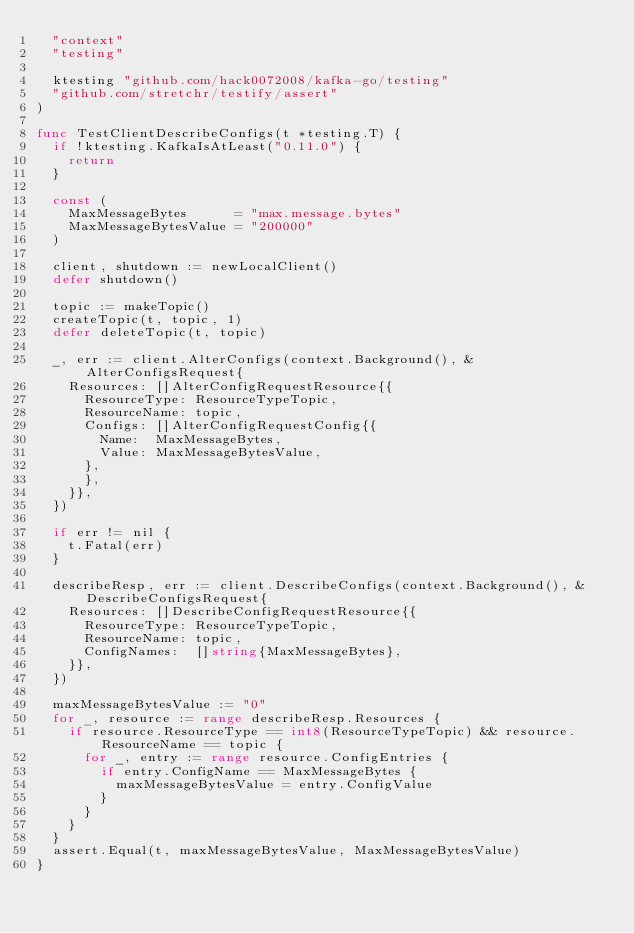Convert code to text. <code><loc_0><loc_0><loc_500><loc_500><_Go_>	"context"
	"testing"

	ktesting "github.com/hack0072008/kafka-go/testing"
	"github.com/stretchr/testify/assert"
)

func TestClientDescribeConfigs(t *testing.T) {
	if !ktesting.KafkaIsAtLeast("0.11.0") {
		return
	}

	const (
		MaxMessageBytes      = "max.message.bytes"
		MaxMessageBytesValue = "200000"
	)

	client, shutdown := newLocalClient()
	defer shutdown()

	topic := makeTopic()
	createTopic(t, topic, 1)
	defer deleteTopic(t, topic)

	_, err := client.AlterConfigs(context.Background(), &AlterConfigsRequest{
		Resources: []AlterConfigRequestResource{{
			ResourceType: ResourceTypeTopic,
			ResourceName: topic,
			Configs: []AlterConfigRequestConfig{{
				Name:  MaxMessageBytes,
				Value: MaxMessageBytesValue,
			},
			},
		}},
	})

	if err != nil {
		t.Fatal(err)
	}

	describeResp, err := client.DescribeConfigs(context.Background(), &DescribeConfigsRequest{
		Resources: []DescribeConfigRequestResource{{
			ResourceType: ResourceTypeTopic,
			ResourceName: topic,
			ConfigNames:  []string{MaxMessageBytes},
		}},
	})

	maxMessageBytesValue := "0"
	for _, resource := range describeResp.Resources {
		if resource.ResourceType == int8(ResourceTypeTopic) && resource.ResourceName == topic {
			for _, entry := range resource.ConfigEntries {
				if entry.ConfigName == MaxMessageBytes {
					maxMessageBytesValue = entry.ConfigValue
				}
			}
		}
	}
	assert.Equal(t, maxMessageBytesValue, MaxMessageBytesValue)
}
</code> 